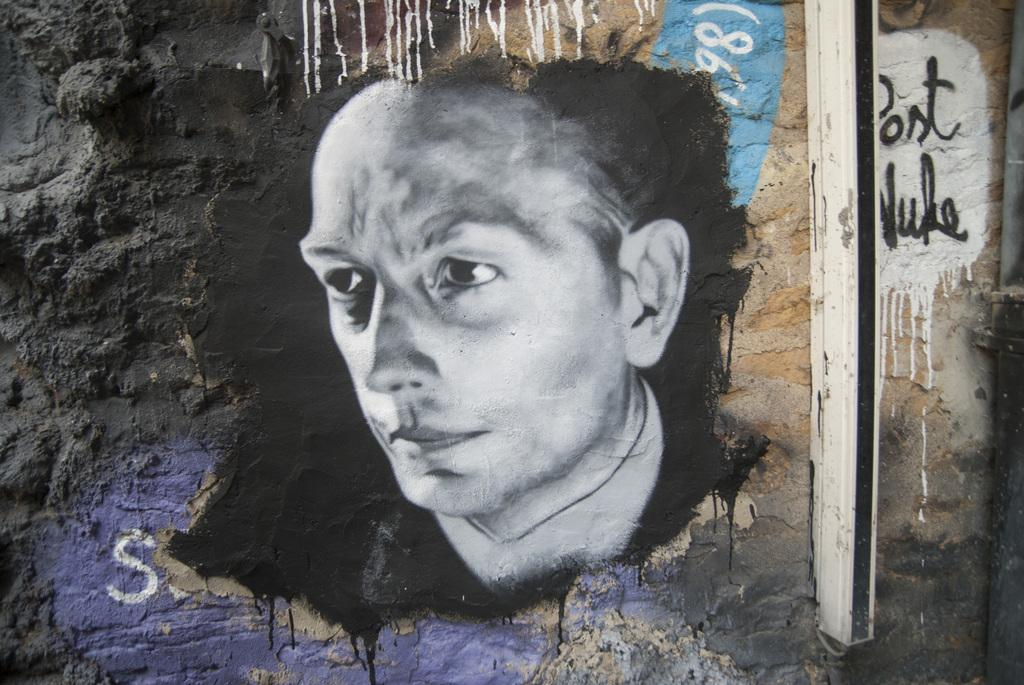What is depicted on the wall in the image? There is a painting of a person on the wall. What else can be seen on the wall besides the painting? There is writing on the wall and an object on the wall. How many faces can be seen on the farm in the image? There is no farm or faces present in the image; it features a painting of a person on the wall, writing, and an object. 